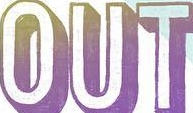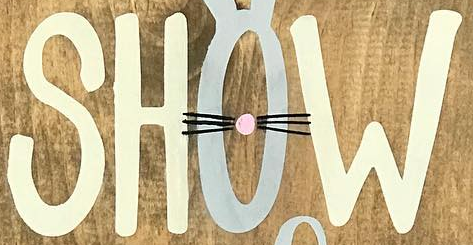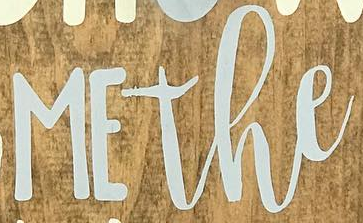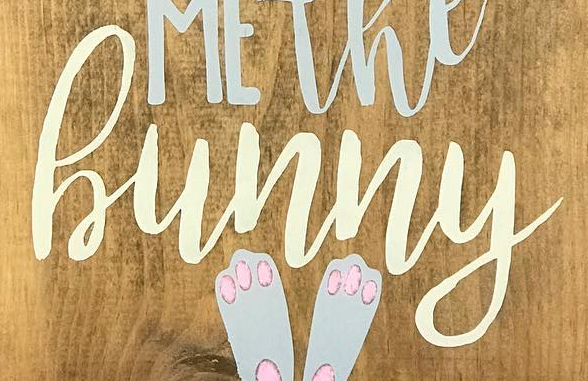What text is displayed in these images sequentially, separated by a semicolon? OUT; SHOW; MEthe; hunny 